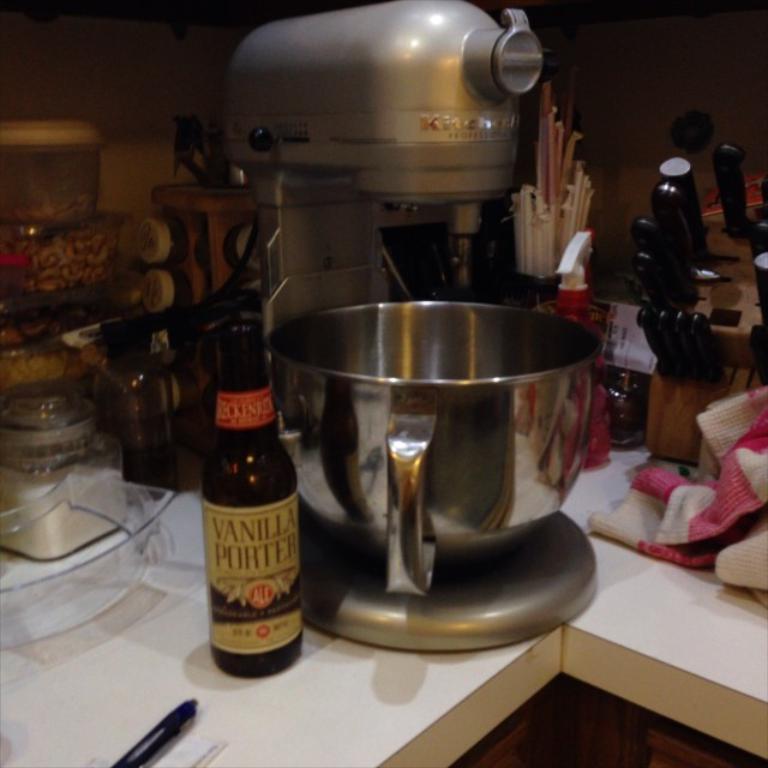Please provide a concise description of this image. In this image we can see a food processor, a bottle, a knife stand and a few objects on a table. 